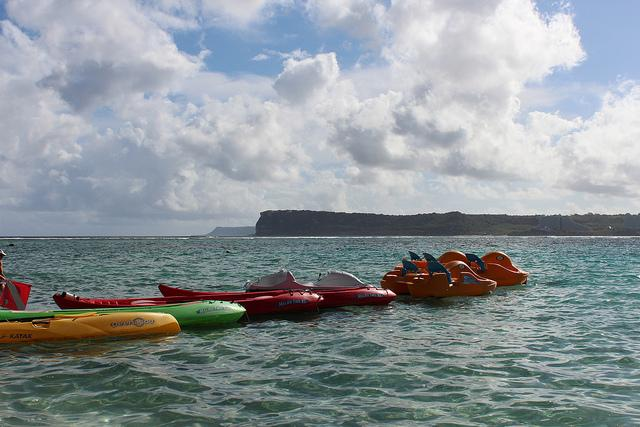What is one of the biggest risks in this environment?

Choices:
A) drowning
B) assault
C) dog assault
D) asphyxiation drowning 